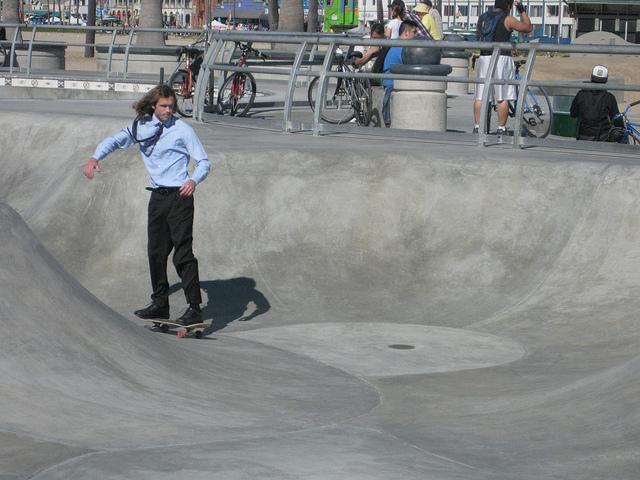Is the boy wearing a helmet?
Be succinct. No. Does he have on the proper attire to be skateboarding?
Write a very short answer. No. Is this man a novice?
Quick response, please. No. Is the skateboarder focused?
Give a very brief answer. Yes. Is the guy proud of his performance?
Concise answer only. Yes. Is this man riding up the side of a skateboard ramp?
Short answer required. No. What is this person standing on?
Concise answer only. Skateboard. Is he having fun?
Short answer required. Yes. 